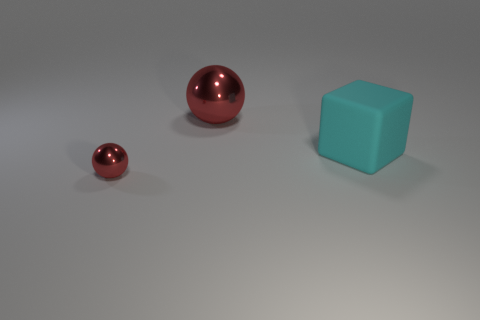Add 3 matte cylinders. How many objects exist? 6 Subtract 2 spheres. How many spheres are left? 0 Subtract all blocks. How many objects are left? 2 Add 3 big gray cylinders. How many big gray cylinders exist? 3 Subtract 0 yellow cubes. How many objects are left? 3 Subtract all brown balls. Subtract all purple cylinders. How many balls are left? 2 Subtract all big brown rubber things. Subtract all large cyan blocks. How many objects are left? 2 Add 1 tiny red things. How many tiny red things are left? 2 